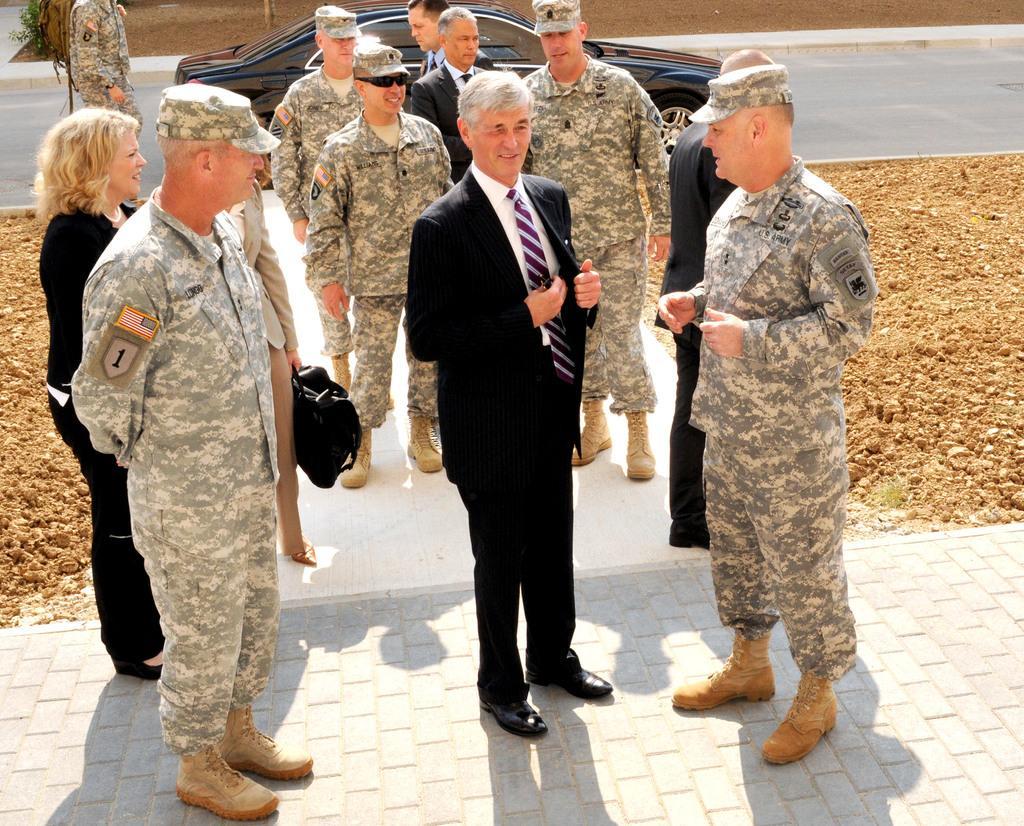Describe this image in one or two sentences. In this image there are people standing on a path, in the background there is a car on a road and there is a man standing near the car, on either side of the path there is soil. 